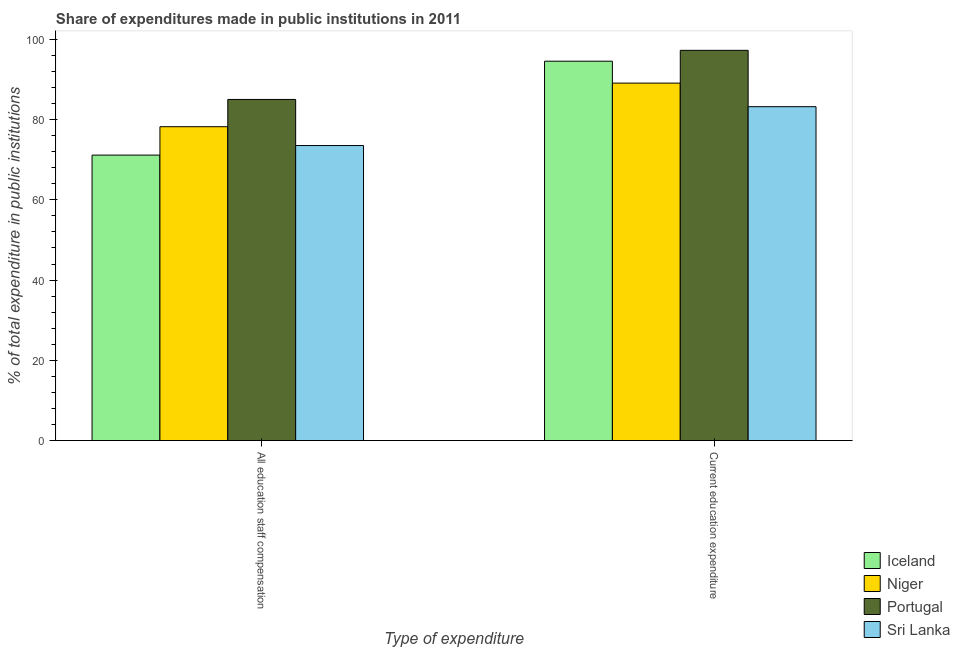How many different coloured bars are there?
Your answer should be compact. 4. How many groups of bars are there?
Give a very brief answer. 2. Are the number of bars per tick equal to the number of legend labels?
Provide a short and direct response. Yes. How many bars are there on the 2nd tick from the left?
Your answer should be compact. 4. How many bars are there on the 1st tick from the right?
Your response must be concise. 4. What is the label of the 2nd group of bars from the left?
Offer a very short reply. Current education expenditure. What is the expenditure in staff compensation in Niger?
Your answer should be compact. 78.21. Across all countries, what is the maximum expenditure in staff compensation?
Your answer should be compact. 85. Across all countries, what is the minimum expenditure in education?
Provide a short and direct response. 83.2. In which country was the expenditure in staff compensation minimum?
Offer a very short reply. Iceland. What is the total expenditure in staff compensation in the graph?
Ensure brevity in your answer.  307.87. What is the difference between the expenditure in staff compensation in Iceland and that in Sri Lanka?
Make the answer very short. -2.38. What is the difference between the expenditure in education in Iceland and the expenditure in staff compensation in Niger?
Offer a very short reply. 16.33. What is the average expenditure in education per country?
Make the answer very short. 91.01. What is the difference between the expenditure in education and expenditure in staff compensation in Sri Lanka?
Keep it short and to the point. 9.68. What is the ratio of the expenditure in education in Portugal to that in Niger?
Your response must be concise. 1.09. In how many countries, is the expenditure in staff compensation greater than the average expenditure in staff compensation taken over all countries?
Provide a short and direct response. 2. What does the 3rd bar from the left in All education staff compensation represents?
Your answer should be very brief. Portugal. Are all the bars in the graph horizontal?
Offer a terse response. No. How many countries are there in the graph?
Provide a short and direct response. 4. What is the difference between two consecutive major ticks on the Y-axis?
Give a very brief answer. 20. What is the title of the graph?
Your answer should be very brief. Share of expenditures made in public institutions in 2011. What is the label or title of the X-axis?
Provide a succinct answer. Type of expenditure. What is the label or title of the Y-axis?
Make the answer very short. % of total expenditure in public institutions. What is the % of total expenditure in public institutions in Iceland in All education staff compensation?
Your response must be concise. 71.14. What is the % of total expenditure in public institutions of Niger in All education staff compensation?
Make the answer very short. 78.21. What is the % of total expenditure in public institutions in Portugal in All education staff compensation?
Offer a terse response. 85. What is the % of total expenditure in public institutions of Sri Lanka in All education staff compensation?
Offer a very short reply. 73.52. What is the % of total expenditure in public institutions of Iceland in Current education expenditure?
Your answer should be compact. 94.54. What is the % of total expenditure in public institutions in Niger in Current education expenditure?
Give a very brief answer. 89.07. What is the % of total expenditure in public institutions of Portugal in Current education expenditure?
Your response must be concise. 97.24. What is the % of total expenditure in public institutions in Sri Lanka in Current education expenditure?
Your answer should be very brief. 83.2. Across all Type of expenditure, what is the maximum % of total expenditure in public institutions of Iceland?
Your answer should be very brief. 94.54. Across all Type of expenditure, what is the maximum % of total expenditure in public institutions in Niger?
Keep it short and to the point. 89.07. Across all Type of expenditure, what is the maximum % of total expenditure in public institutions in Portugal?
Your answer should be very brief. 97.24. Across all Type of expenditure, what is the maximum % of total expenditure in public institutions in Sri Lanka?
Provide a short and direct response. 83.2. Across all Type of expenditure, what is the minimum % of total expenditure in public institutions of Iceland?
Make the answer very short. 71.14. Across all Type of expenditure, what is the minimum % of total expenditure in public institutions in Niger?
Your response must be concise. 78.21. Across all Type of expenditure, what is the minimum % of total expenditure in public institutions in Portugal?
Keep it short and to the point. 85. Across all Type of expenditure, what is the minimum % of total expenditure in public institutions of Sri Lanka?
Ensure brevity in your answer.  73.52. What is the total % of total expenditure in public institutions of Iceland in the graph?
Provide a succinct answer. 165.67. What is the total % of total expenditure in public institutions in Niger in the graph?
Offer a very short reply. 167.28. What is the total % of total expenditure in public institutions in Portugal in the graph?
Your response must be concise. 182.25. What is the total % of total expenditure in public institutions of Sri Lanka in the graph?
Ensure brevity in your answer.  156.72. What is the difference between the % of total expenditure in public institutions in Iceland in All education staff compensation and that in Current education expenditure?
Provide a succinct answer. -23.4. What is the difference between the % of total expenditure in public institutions of Niger in All education staff compensation and that in Current education expenditure?
Offer a terse response. -10.86. What is the difference between the % of total expenditure in public institutions of Portugal in All education staff compensation and that in Current education expenditure?
Provide a succinct answer. -12.24. What is the difference between the % of total expenditure in public institutions of Sri Lanka in All education staff compensation and that in Current education expenditure?
Give a very brief answer. -9.68. What is the difference between the % of total expenditure in public institutions in Iceland in All education staff compensation and the % of total expenditure in public institutions in Niger in Current education expenditure?
Offer a terse response. -17.94. What is the difference between the % of total expenditure in public institutions in Iceland in All education staff compensation and the % of total expenditure in public institutions in Portugal in Current education expenditure?
Ensure brevity in your answer.  -26.1. What is the difference between the % of total expenditure in public institutions of Iceland in All education staff compensation and the % of total expenditure in public institutions of Sri Lanka in Current education expenditure?
Offer a very short reply. -12.06. What is the difference between the % of total expenditure in public institutions of Niger in All education staff compensation and the % of total expenditure in public institutions of Portugal in Current education expenditure?
Your response must be concise. -19.03. What is the difference between the % of total expenditure in public institutions of Niger in All education staff compensation and the % of total expenditure in public institutions of Sri Lanka in Current education expenditure?
Make the answer very short. -4.99. What is the difference between the % of total expenditure in public institutions in Portugal in All education staff compensation and the % of total expenditure in public institutions in Sri Lanka in Current education expenditure?
Provide a succinct answer. 1.8. What is the average % of total expenditure in public institutions in Iceland per Type of expenditure?
Offer a very short reply. 82.84. What is the average % of total expenditure in public institutions of Niger per Type of expenditure?
Give a very brief answer. 83.64. What is the average % of total expenditure in public institutions of Portugal per Type of expenditure?
Offer a terse response. 91.12. What is the average % of total expenditure in public institutions in Sri Lanka per Type of expenditure?
Your response must be concise. 78.36. What is the difference between the % of total expenditure in public institutions in Iceland and % of total expenditure in public institutions in Niger in All education staff compensation?
Ensure brevity in your answer.  -7.07. What is the difference between the % of total expenditure in public institutions of Iceland and % of total expenditure in public institutions of Portugal in All education staff compensation?
Offer a terse response. -13.87. What is the difference between the % of total expenditure in public institutions of Iceland and % of total expenditure in public institutions of Sri Lanka in All education staff compensation?
Ensure brevity in your answer.  -2.38. What is the difference between the % of total expenditure in public institutions of Niger and % of total expenditure in public institutions of Portugal in All education staff compensation?
Offer a terse response. -6.79. What is the difference between the % of total expenditure in public institutions of Niger and % of total expenditure in public institutions of Sri Lanka in All education staff compensation?
Offer a terse response. 4.69. What is the difference between the % of total expenditure in public institutions in Portugal and % of total expenditure in public institutions in Sri Lanka in All education staff compensation?
Offer a very short reply. 11.48. What is the difference between the % of total expenditure in public institutions in Iceland and % of total expenditure in public institutions in Niger in Current education expenditure?
Your response must be concise. 5.46. What is the difference between the % of total expenditure in public institutions of Iceland and % of total expenditure in public institutions of Portugal in Current education expenditure?
Provide a succinct answer. -2.71. What is the difference between the % of total expenditure in public institutions in Iceland and % of total expenditure in public institutions in Sri Lanka in Current education expenditure?
Offer a very short reply. 11.33. What is the difference between the % of total expenditure in public institutions of Niger and % of total expenditure in public institutions of Portugal in Current education expenditure?
Provide a succinct answer. -8.17. What is the difference between the % of total expenditure in public institutions in Niger and % of total expenditure in public institutions in Sri Lanka in Current education expenditure?
Ensure brevity in your answer.  5.87. What is the difference between the % of total expenditure in public institutions in Portugal and % of total expenditure in public institutions in Sri Lanka in Current education expenditure?
Give a very brief answer. 14.04. What is the ratio of the % of total expenditure in public institutions in Iceland in All education staff compensation to that in Current education expenditure?
Provide a short and direct response. 0.75. What is the ratio of the % of total expenditure in public institutions in Niger in All education staff compensation to that in Current education expenditure?
Offer a very short reply. 0.88. What is the ratio of the % of total expenditure in public institutions of Portugal in All education staff compensation to that in Current education expenditure?
Your answer should be very brief. 0.87. What is the ratio of the % of total expenditure in public institutions in Sri Lanka in All education staff compensation to that in Current education expenditure?
Keep it short and to the point. 0.88. What is the difference between the highest and the second highest % of total expenditure in public institutions of Iceland?
Give a very brief answer. 23.4. What is the difference between the highest and the second highest % of total expenditure in public institutions in Niger?
Keep it short and to the point. 10.86. What is the difference between the highest and the second highest % of total expenditure in public institutions in Portugal?
Your answer should be very brief. 12.24. What is the difference between the highest and the second highest % of total expenditure in public institutions in Sri Lanka?
Your response must be concise. 9.68. What is the difference between the highest and the lowest % of total expenditure in public institutions in Iceland?
Give a very brief answer. 23.4. What is the difference between the highest and the lowest % of total expenditure in public institutions of Niger?
Provide a succinct answer. 10.86. What is the difference between the highest and the lowest % of total expenditure in public institutions in Portugal?
Make the answer very short. 12.24. What is the difference between the highest and the lowest % of total expenditure in public institutions of Sri Lanka?
Give a very brief answer. 9.68. 